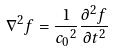Convert formula to latex. <formula><loc_0><loc_0><loc_500><loc_500>\nabla ^ { 2 } f = \frac { 1 } { { c _ { 0 } } ^ { 2 } } \frac { \partial ^ { 2 } f } { \partial t ^ { 2 } }</formula> 